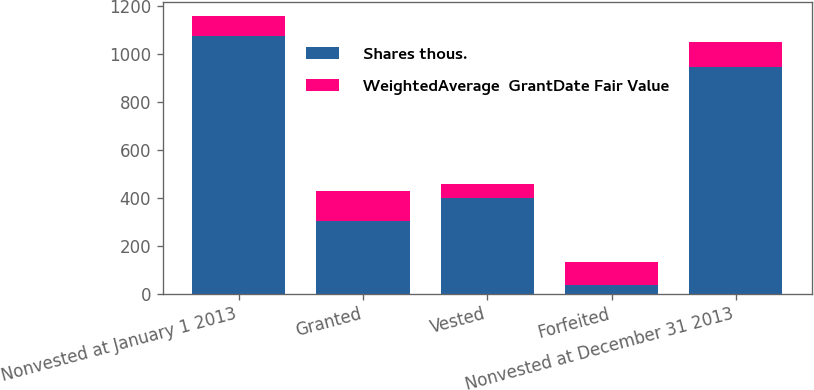Convert chart. <chart><loc_0><loc_0><loc_500><loc_500><stacked_bar_chart><ecel><fcel>Nonvested at January 1 2013<fcel>Granted<fcel>Vested<fcel>Forfeited<fcel>Nonvested at December 31 2013<nl><fcel>Shares thous.<fcel>1075<fcel>304<fcel>401<fcel>34<fcel>944<nl><fcel>WeightedAverage  GrantDate Fair Value<fcel>83.8<fcel>125.14<fcel>58.33<fcel>98.69<fcel>107.4<nl></chart> 